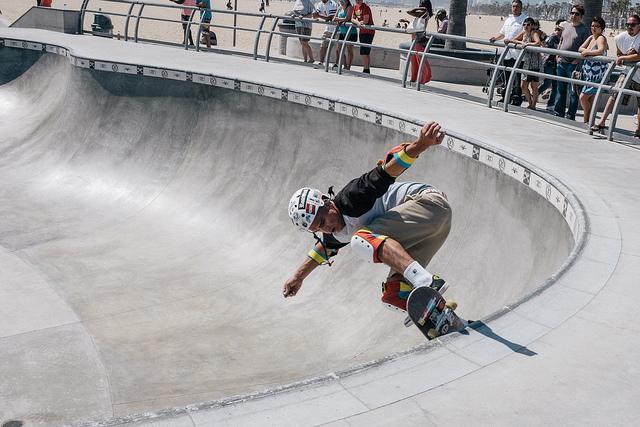How many people can you see?
Give a very brief answer. 3. How many legs does the bench have?
Give a very brief answer. 0. 